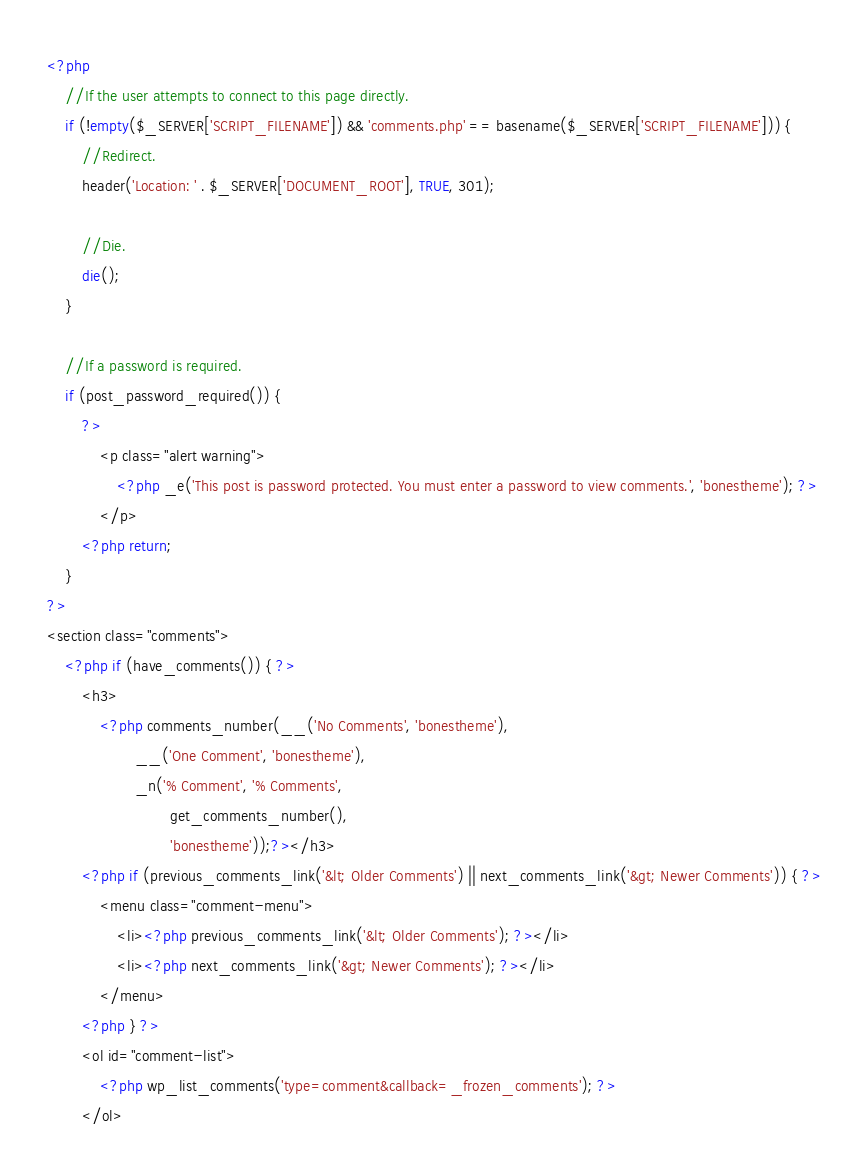<code> <loc_0><loc_0><loc_500><loc_500><_PHP_><?php
	//If the user attempts to connect to this page directly.
	if (!empty($_SERVER['SCRIPT_FILENAME']) && 'comments.php' == basename($_SERVER['SCRIPT_FILENAME'])) {
		//Redirect.
		header('Location: ' . $_SERVER['DOCUMENT_ROOT'], TRUE, 301);
		
		//Die.
		die();
	} 
	
	//If a password is required. 
	if (post_password_required()) {
		?>
			<p class="alert warning">
				<?php _e('This post is password protected. You must enter a password to view comments.', 'bonestheme'); ?>
			</p>
		<?php return;
	}
?>
<section class="comments">
	<?php if (have_comments()) { ?>
		<h3>
			<?php comments_number(__('No Comments', 'bonestheme'),
					__('One Comment', 'bonestheme'),
					_n('% Comment', '% Comments', 
							get_comments_number(), 
							'bonestheme'));?></h3>
		<?php if (previous_comments_link('&lt; Older Comments') || next_comments_link('&gt; Newer Comments')) { ?>
			<menu class="comment-menu">
				<li><?php previous_comments_link('&lt; Older Comments'); ?></li>
				<li><?php next_comments_link('&gt; Newer Comments'); ?></li>
			</menu>
		<?php } ?>
		<ol id="comment-list">
			<?php wp_list_comments('type=comment&callback=_frozen_comments'); ?>
		</ol></code> 